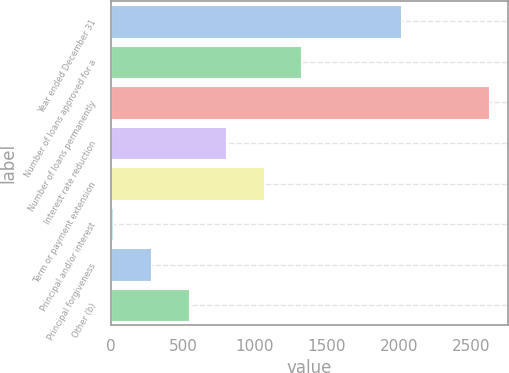<chart> <loc_0><loc_0><loc_500><loc_500><bar_chart><fcel>Year ended December 31<fcel>Number of loans approved for a<fcel>Number of loans permanently<fcel>Interest rate reduction<fcel>Term or payment extension<fcel>Principal and/or interest<fcel>Principal forgiveness<fcel>Other (b)<nl><fcel>2017<fcel>1321.5<fcel>2628<fcel>798.9<fcel>1060.2<fcel>15<fcel>276.3<fcel>537.6<nl></chart> 